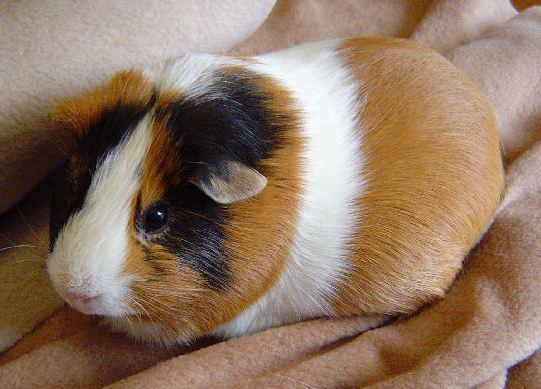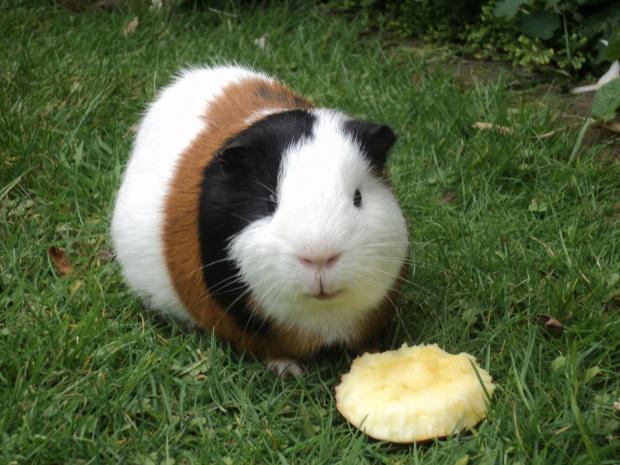The first image is the image on the left, the second image is the image on the right. For the images displayed, is the sentence "There are two hamsters." factually correct? Answer yes or no. Yes. 